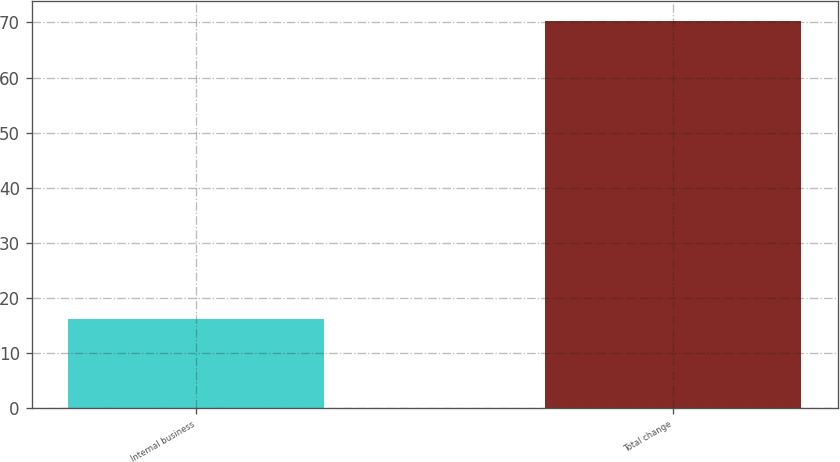Convert chart. <chart><loc_0><loc_0><loc_500><loc_500><bar_chart><fcel>Internal business<fcel>Total change<nl><fcel>16.2<fcel>70.3<nl></chart> 